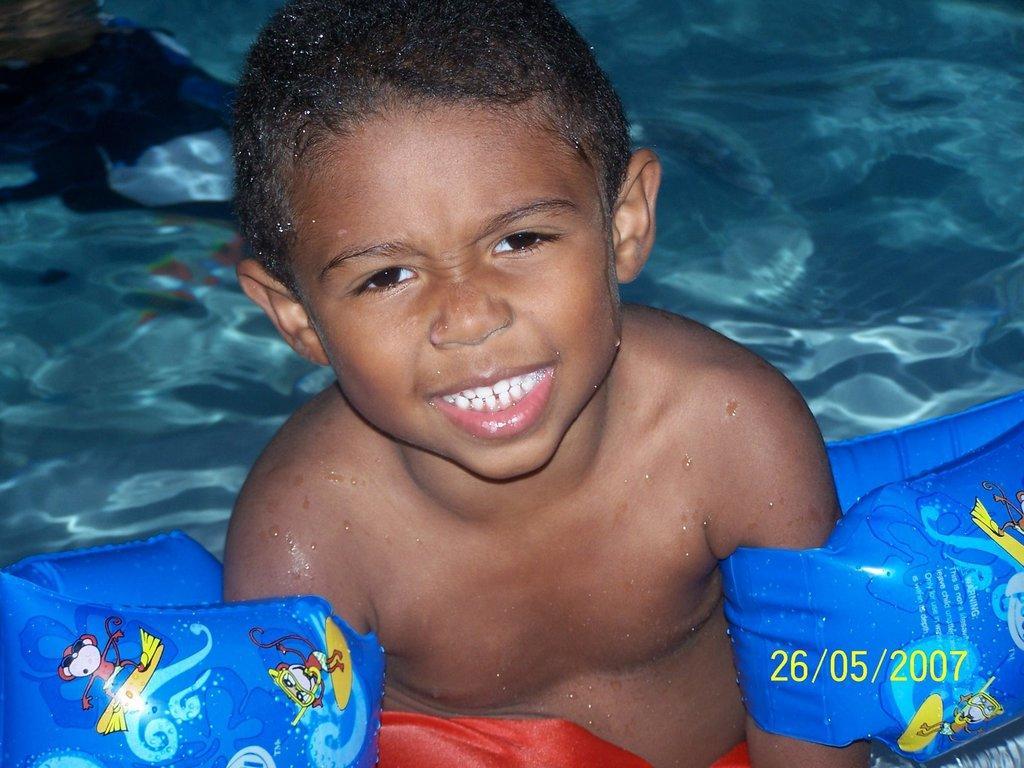Could you give a brief overview of what you see in this image? In the image a boy is swimming in the water. 